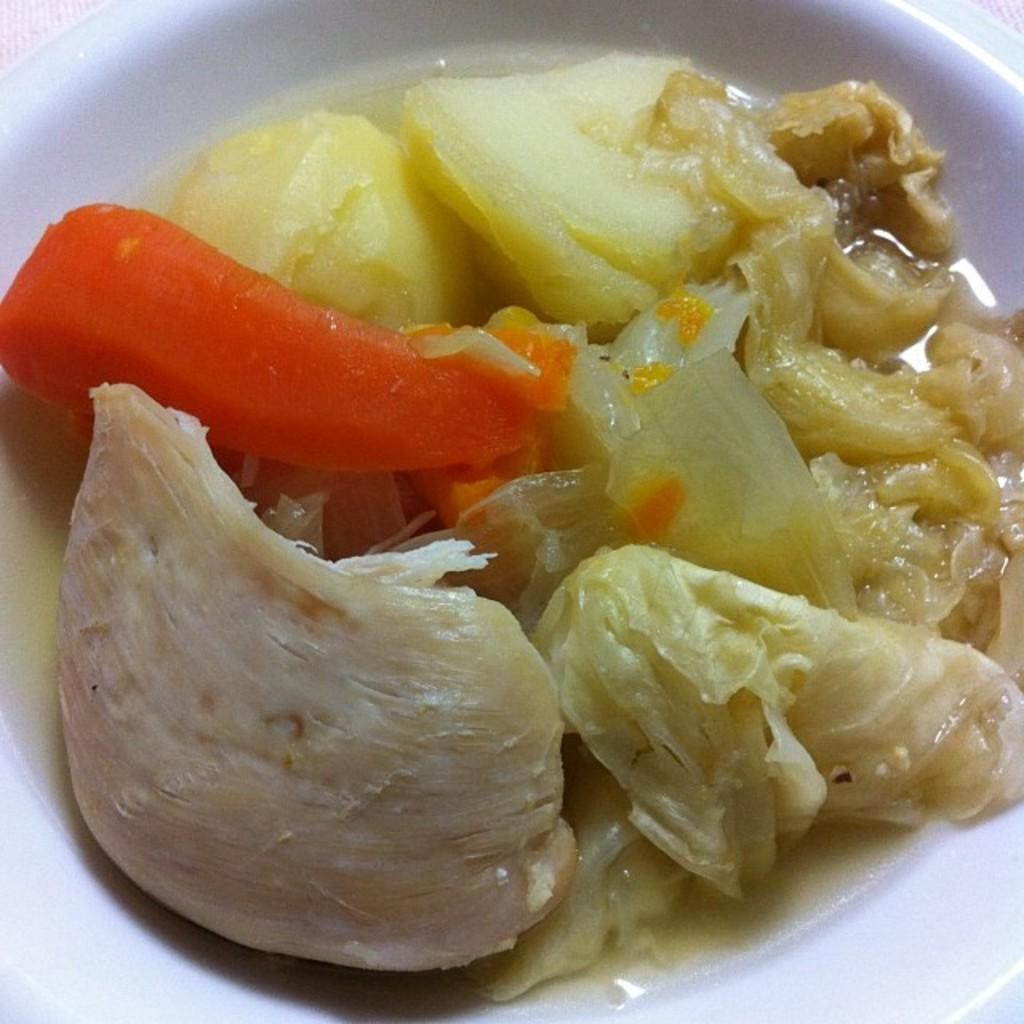What is in the bowl that is visible in the image? There is a bowl in the image. What type of food is in the bowl? The bowl contains a food item. Can you identify the specific food items in the bowl? Boiled carrots and boiled potatoes are present in the bowl. What color is the orange in the brain of the person in the image? There is no orange or brain present in the image; it only shows a bowl with boiled carrots and boiled potatoes. 